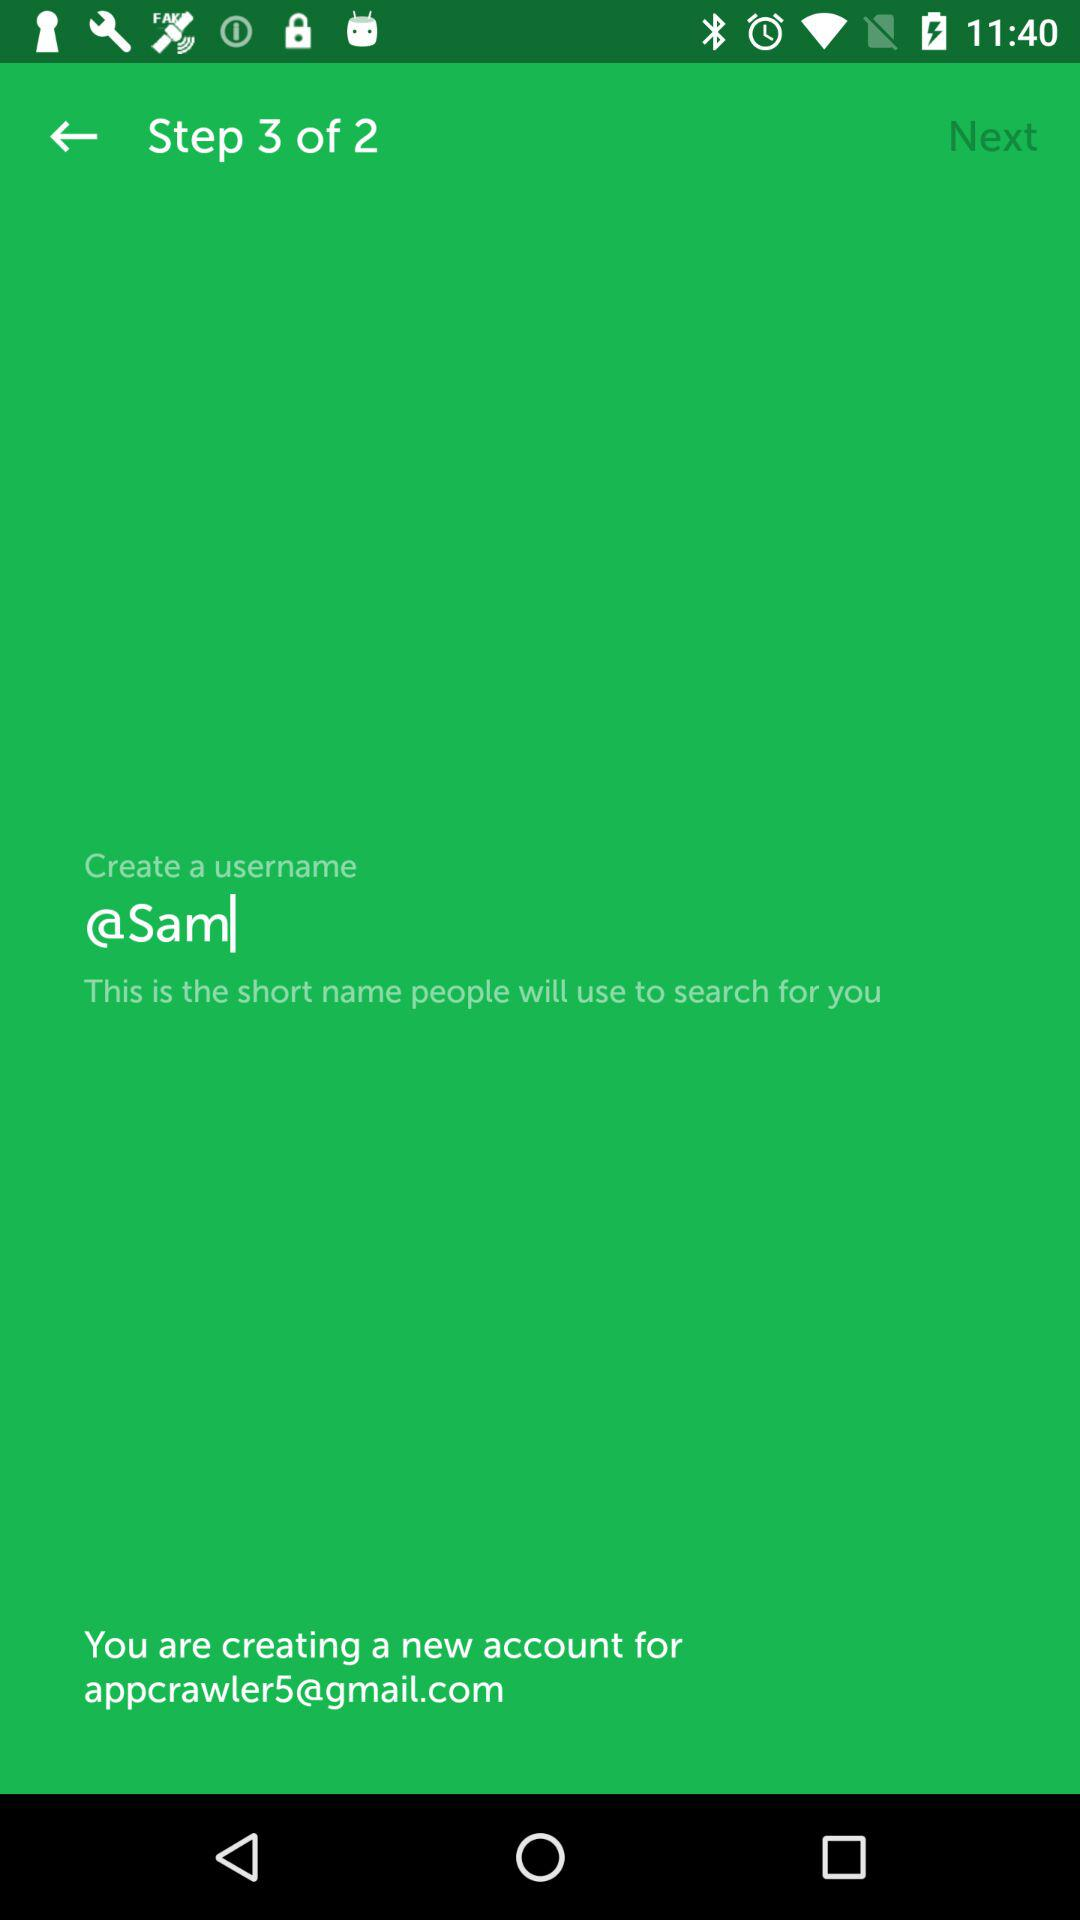What is the created username? The created username is "@Sam". 